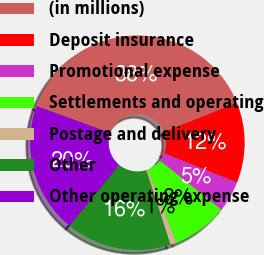Convert chart. <chart><loc_0><loc_0><loc_500><loc_500><pie_chart><fcel>(in millions)<fcel>Deposit insurance<fcel>Promotional expense<fcel>Settlements and operating<fcel>Postage and delivery<fcel>Other<fcel>Other operating expense<nl><fcel>38.35%<fcel>12.15%<fcel>4.66%<fcel>8.4%<fcel>0.91%<fcel>15.89%<fcel>19.63%<nl></chart> 